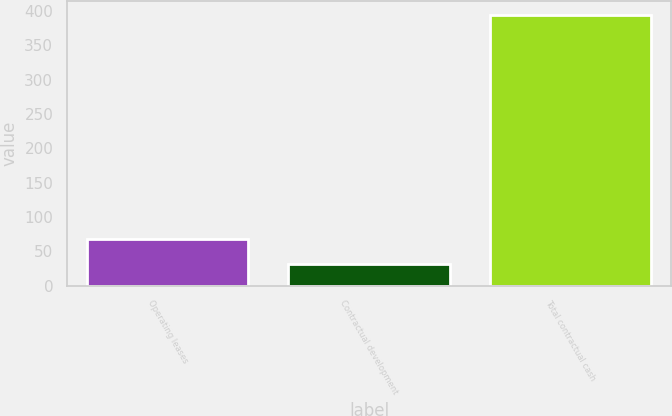<chart> <loc_0><loc_0><loc_500><loc_500><bar_chart><fcel>Operating leases<fcel>Contractual development<fcel>Total contractual cash<nl><fcel>68.19<fcel>31.9<fcel>394.8<nl></chart> 